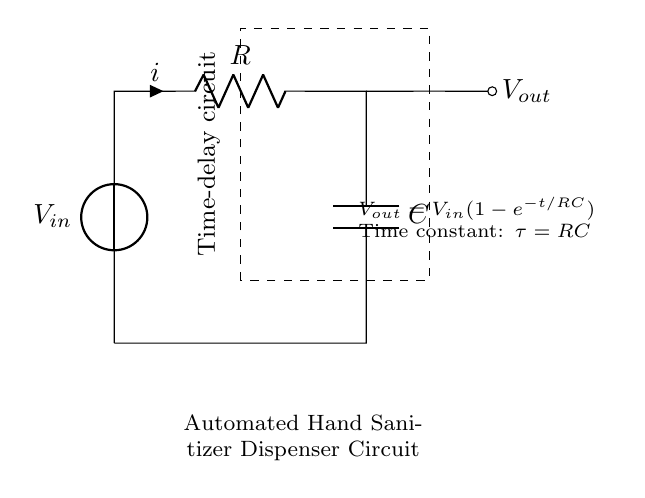What is the input voltage in this circuit? The input voltage is represented as V sub in in the circuit diagram, which is an unspecified source.
Answer: V sub in What components are used in this circuit? The circuit includes a voltage source, a resistor, and a capacitor. Each component is labeled in the diagram.
Answer: Voltage source, resistor, capacitor What is the relationship between output voltage and time? The output voltage increases over time according to the formula given: V sub out equals V sub in times one minus e raised to the negative t over RC. This indicates an exponential rise based on time.
Answer: Exponential rise What does the time constant represent? The time constant, denoted by tau, is equal to the product of resistance and capacitance (RC), which indicates how quickly the voltage can change over time.
Answer: RC What does the dashed rectangle indicate? The dashed rectangle signifies the boundary of the time-delay circuit, highlighting its functional area within the system.
Answer: Time-delay circuit How does increasing the resistance affect the time constant? Increasing the resistance directly increases the time constant, making the circuit take longer to reach the output voltage since tau equals RC.
Answer: Increases time constant 